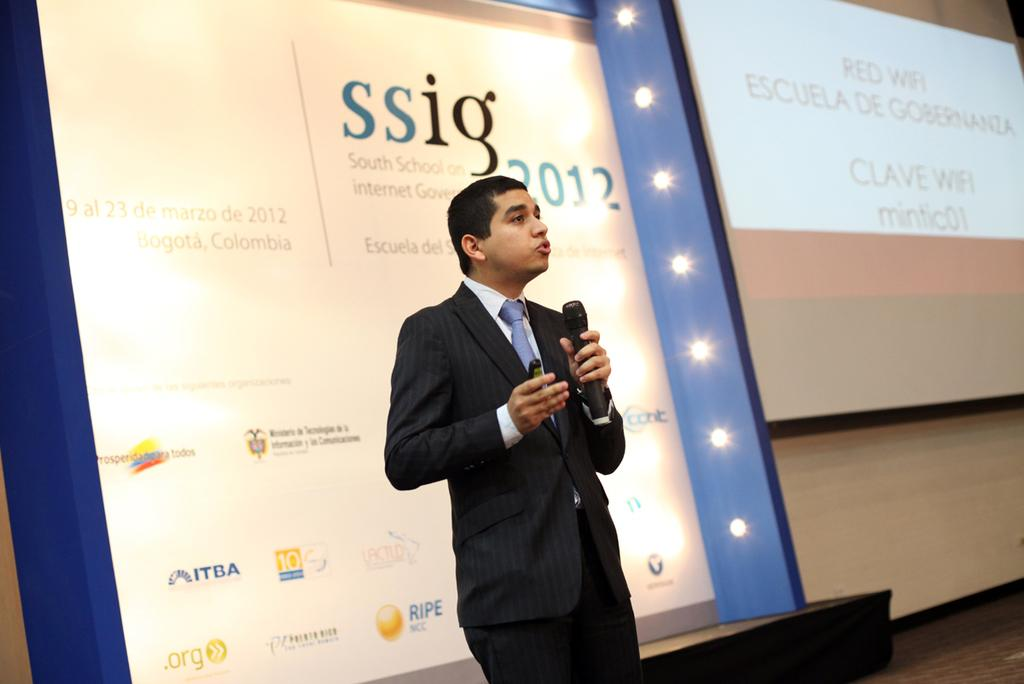What is the man in the image wearing? The man is wearing a blazer and a tie. What is the man holding in his hand? The man is holding a mic in his hand. What is the man doing in the image? The man is talking. What can be seen in the background of the image? There is a banner, a screen, and lights in the background of the image. How many pizzas are being served at the nation's event in the image? There is no information about pizzas or a nation's event in the image. 